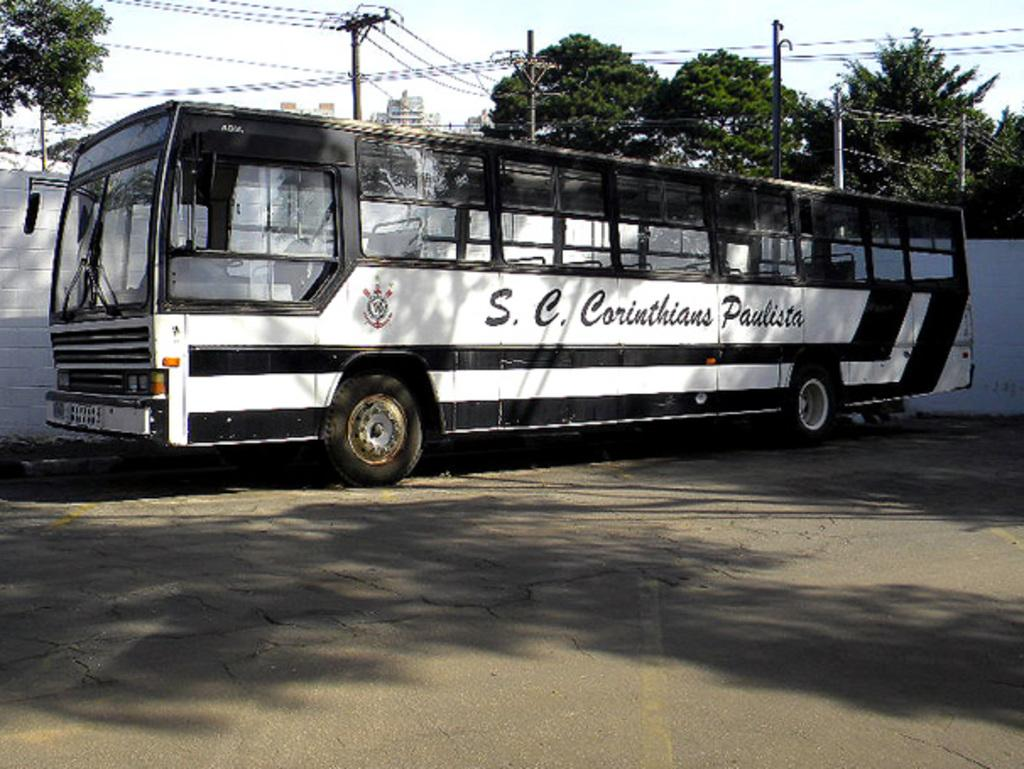What is parked on the road in the image? There is a bus parked on the road in the image. What is behind the road in the image? There is a wall behind the road in the image. What can be seen on the electric poles in the image? Electric poles with cables are present in the image. What is visible behind the poles in the image? Trees are visible behind the poles in the image. What is in the background of the image? Buildings are present in the background of the image. What is visible at the top of the image? The sky is visible in the image. Where is the shelf located in the image? There is no shelf present in the image. What does the bus look like in the image? The question is not absurd, as it can be answered based on the facts provided. The bus is parked on the road in the image. 